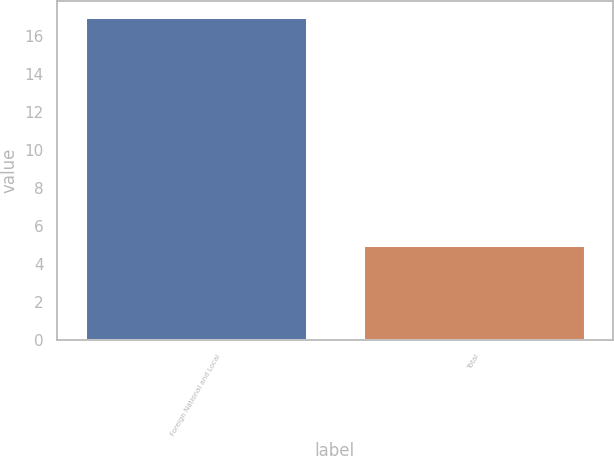Convert chart to OTSL. <chart><loc_0><loc_0><loc_500><loc_500><bar_chart><fcel>Foreign National and Local<fcel>Total<nl><fcel>17<fcel>5<nl></chart> 